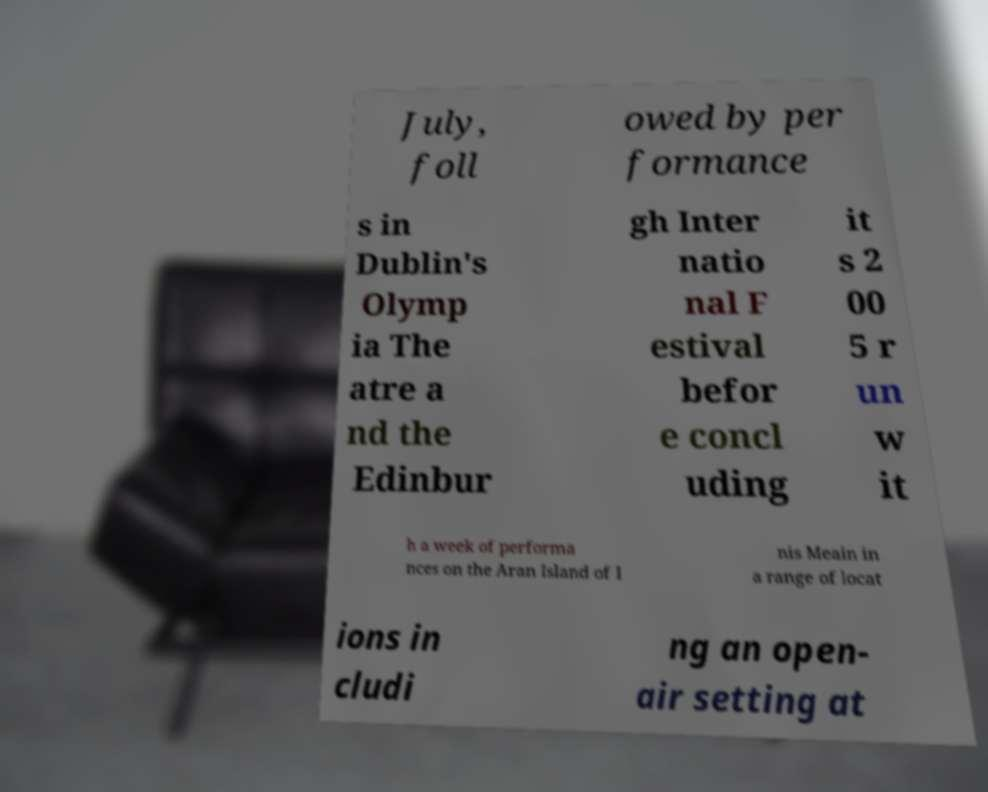I need the written content from this picture converted into text. Can you do that? July, foll owed by per formance s in Dublin's Olymp ia The atre a nd the Edinbur gh Inter natio nal F estival befor e concl uding it s 2 00 5 r un w it h a week of performa nces on the Aran Island of I nis Meain in a range of locat ions in cludi ng an open- air setting at 